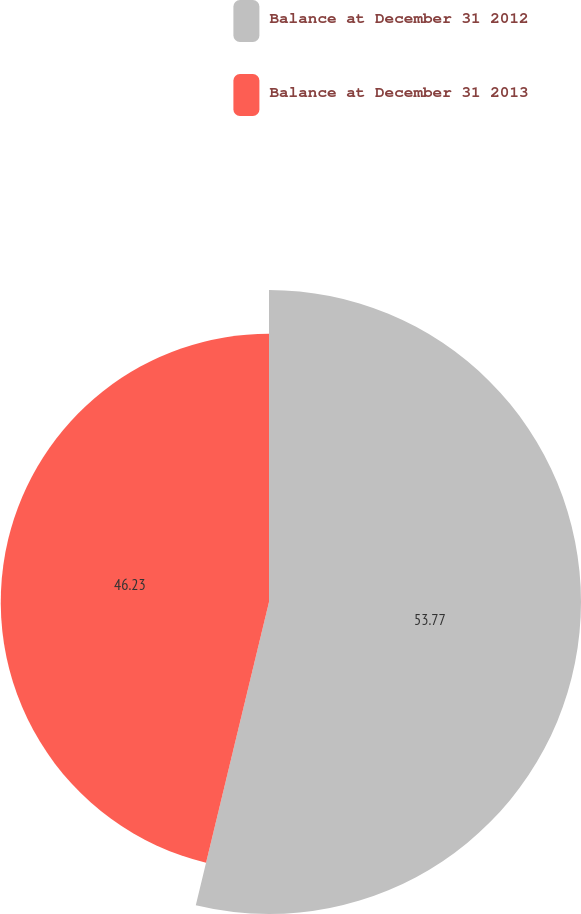<chart> <loc_0><loc_0><loc_500><loc_500><pie_chart><fcel>Balance at December 31 2012<fcel>Balance at December 31 2013<nl><fcel>53.77%<fcel>46.23%<nl></chart> 